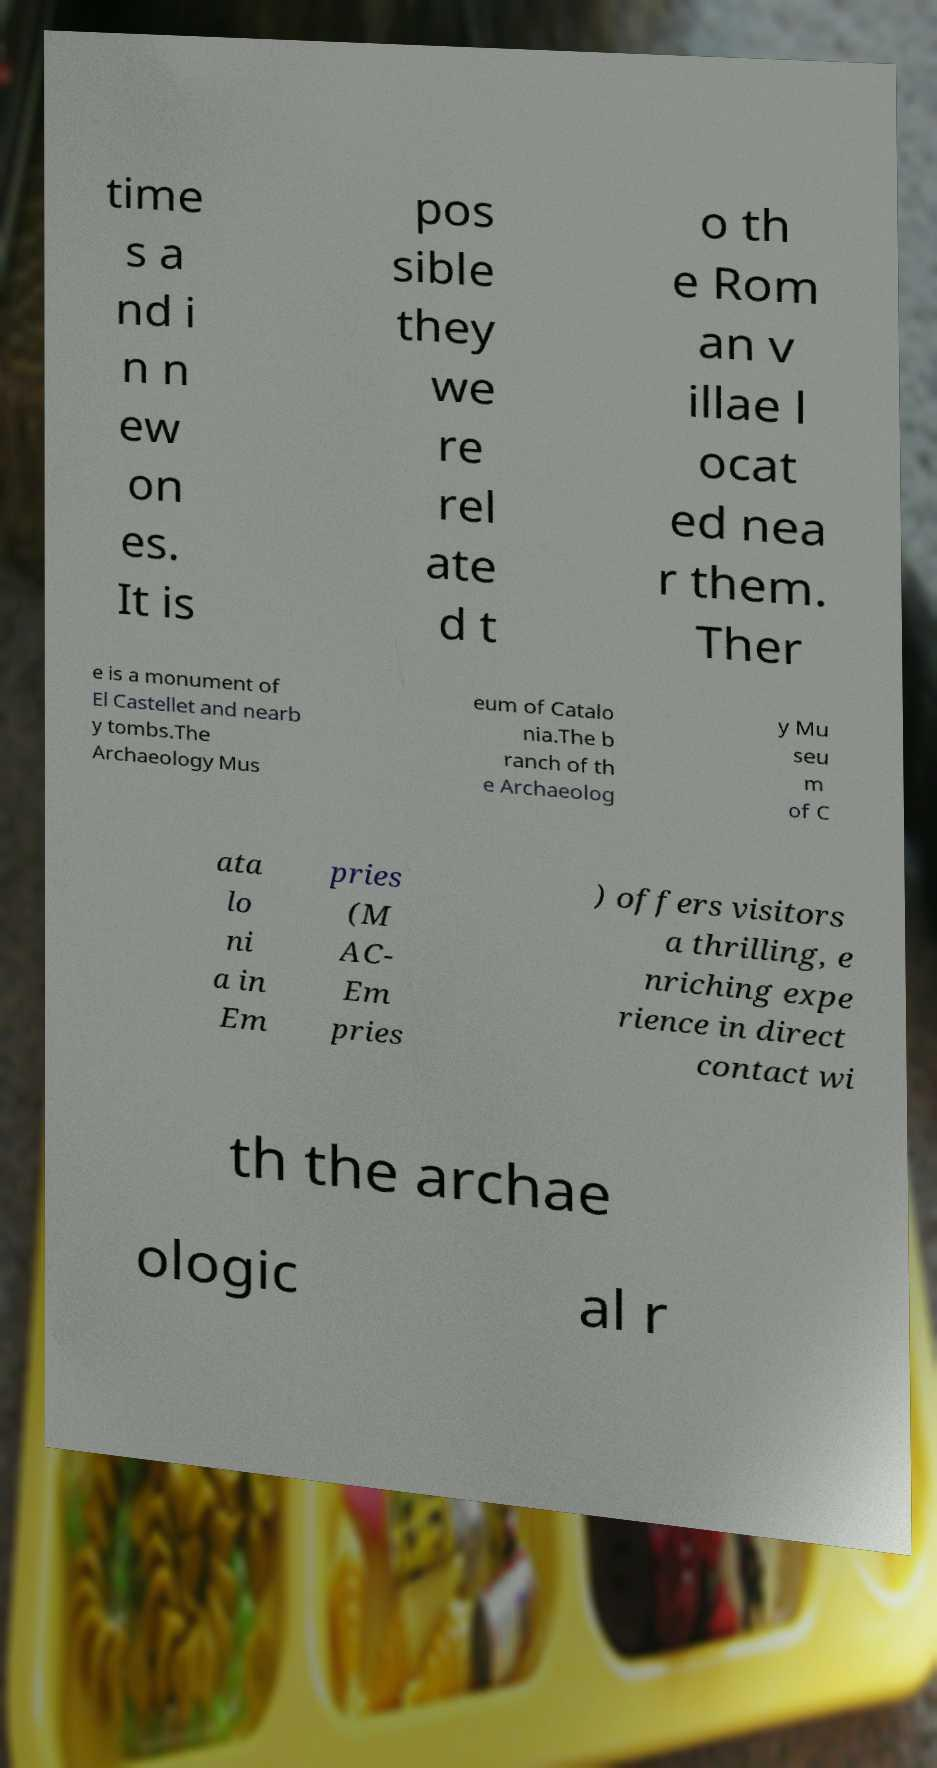Could you assist in decoding the text presented in this image and type it out clearly? time s a nd i n n ew on es. It is pos sible they we re rel ate d t o th e Rom an v illae l ocat ed nea r them. Ther e is a monument of El Castellet and nearb y tombs.The Archaeology Mus eum of Catalo nia.The b ranch of th e Archaeolog y Mu seu m of C ata lo ni a in Em pries (M AC- Em pries ) offers visitors a thrilling, e nriching expe rience in direct contact wi th the archae ologic al r 